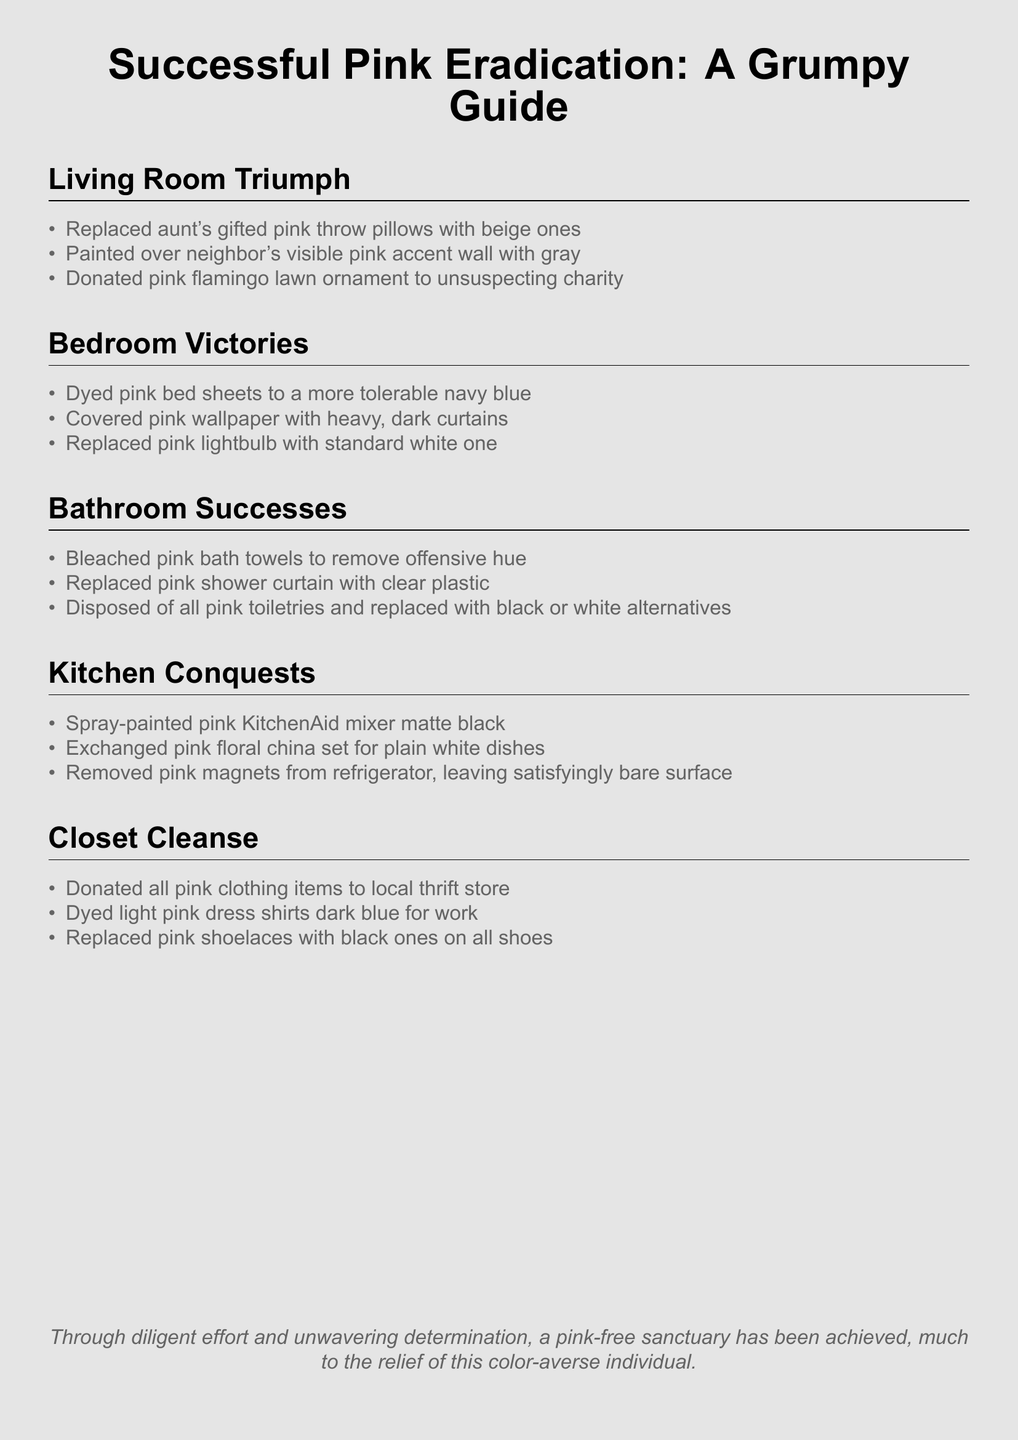What is the title of the document? The title is provided at the beginning of the document.
Answer: Successful Pink Eradication: A Grumpy Guide How many sections are in the document? The sections of the document are clearly listed.
Answer: Five What color were the replaced throw pillows? The document states the original color of the pillows and their replacement color.
Answer: Beige Which room did the pink flamingo lawn ornament get donated from? The information comes from the section detailing living room actions.
Answer: Living Room What color were the bed sheets dyed to? The document specifically mentions the new color of the bed sheets.
Answer: Navy blue What was the fate of the pink shower curtain? The document outlines what happened to the pink shower curtain in the bathroom.
Answer: Clear plastic Which appliances had their color changed? This question focuses on the kitchen section's attempts to eradicate pink.
Answer: KitchenAid mixer What was done with pink clothing items? The closet section specifies the outcome of the pink clothing.
Answer: Donated to local thrift store What is the tone of the conclusion? The conclusion summarizes the overall sentiment expressed throughout the document.
Answer: Relief 